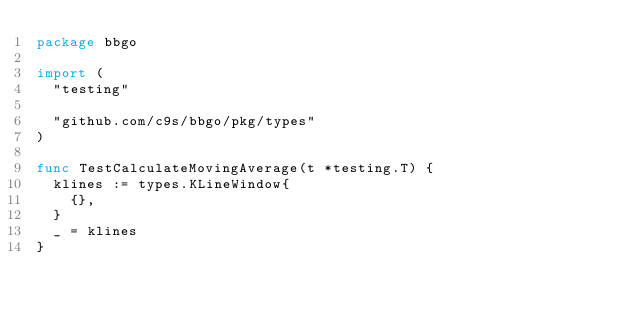Convert code to text. <code><loc_0><loc_0><loc_500><loc_500><_Go_>package bbgo

import (
	"testing"

	"github.com/c9s/bbgo/pkg/types"
)

func TestCalculateMovingAverage(t *testing.T) {
	klines := types.KLineWindow{
		{},
	}
	_ = klines
}
</code> 